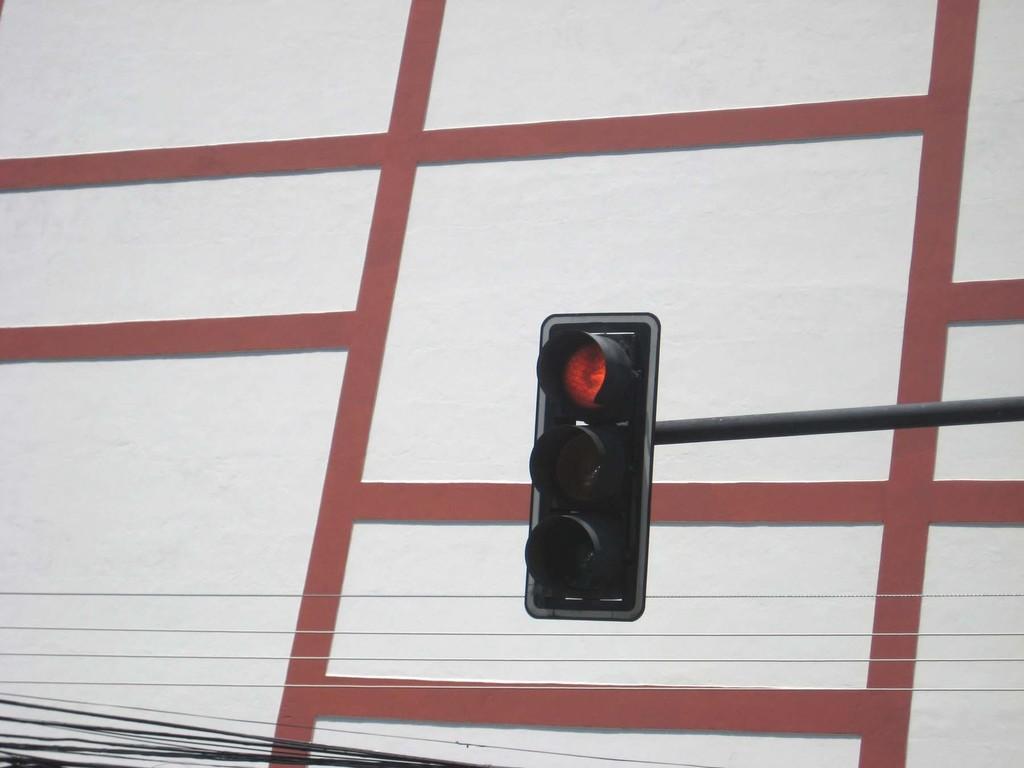Could you give a brief overview of what you see in this image? In this picture we can see traffic lights and a metal rod in the middle, there are some wires at the bottom, it looks like a wall in the background. 